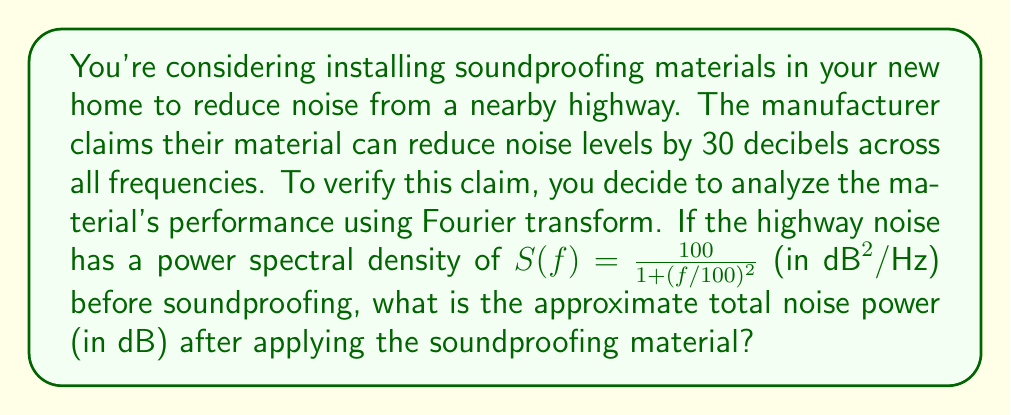Can you answer this question? To solve this problem, we'll follow these steps:

1) The power spectral density (PSD) of the noise before soundproofing is given by:

   $$S(f) = \frac{100}{1 + (f/100)^2}$$

2) The total noise power is the integral of the PSD over all frequencies. In this case, we can integrate from 0 to infinity:

   $$P_{\text{total}} = \int_0^{\infty} S(f) df$$

3) This integral can be solved analytically:

   $$P_{\text{total}} = 100 \cdot \arctan(f/100)|_0^{\infty} = 100 \cdot \frac{\pi}{2} = 50\pi$$

4) To convert this to decibels, we use the formula:

   $$P_{\text{dB}} = 10 \log_{10}(P_{\text{total}})$$

5) Substituting our value:

   $$P_{\text{dB}} = 10 \log_{10}(50\pi) \approx 21.98 \text{ dB}$$

6) The soundproofing material reduces this by 30 dB across all frequencies. So the noise power after soundproofing is:

   $$P_{\text{after}} = 21.98 - 30 = -8.02 \text{ dB}$$

Thus, the approximate total noise power after applying the soundproofing material is -8.02 dB.
Answer: -8.02 dB 